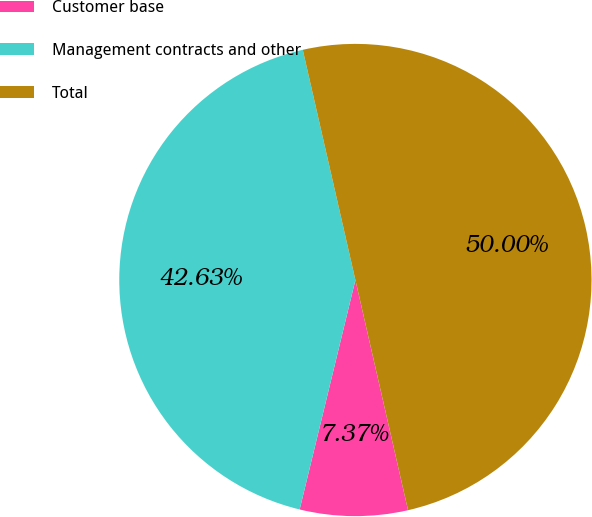Convert chart. <chart><loc_0><loc_0><loc_500><loc_500><pie_chart><fcel>Customer base<fcel>Management contracts and other<fcel>Total<nl><fcel>7.37%<fcel>42.63%<fcel>50.0%<nl></chart> 